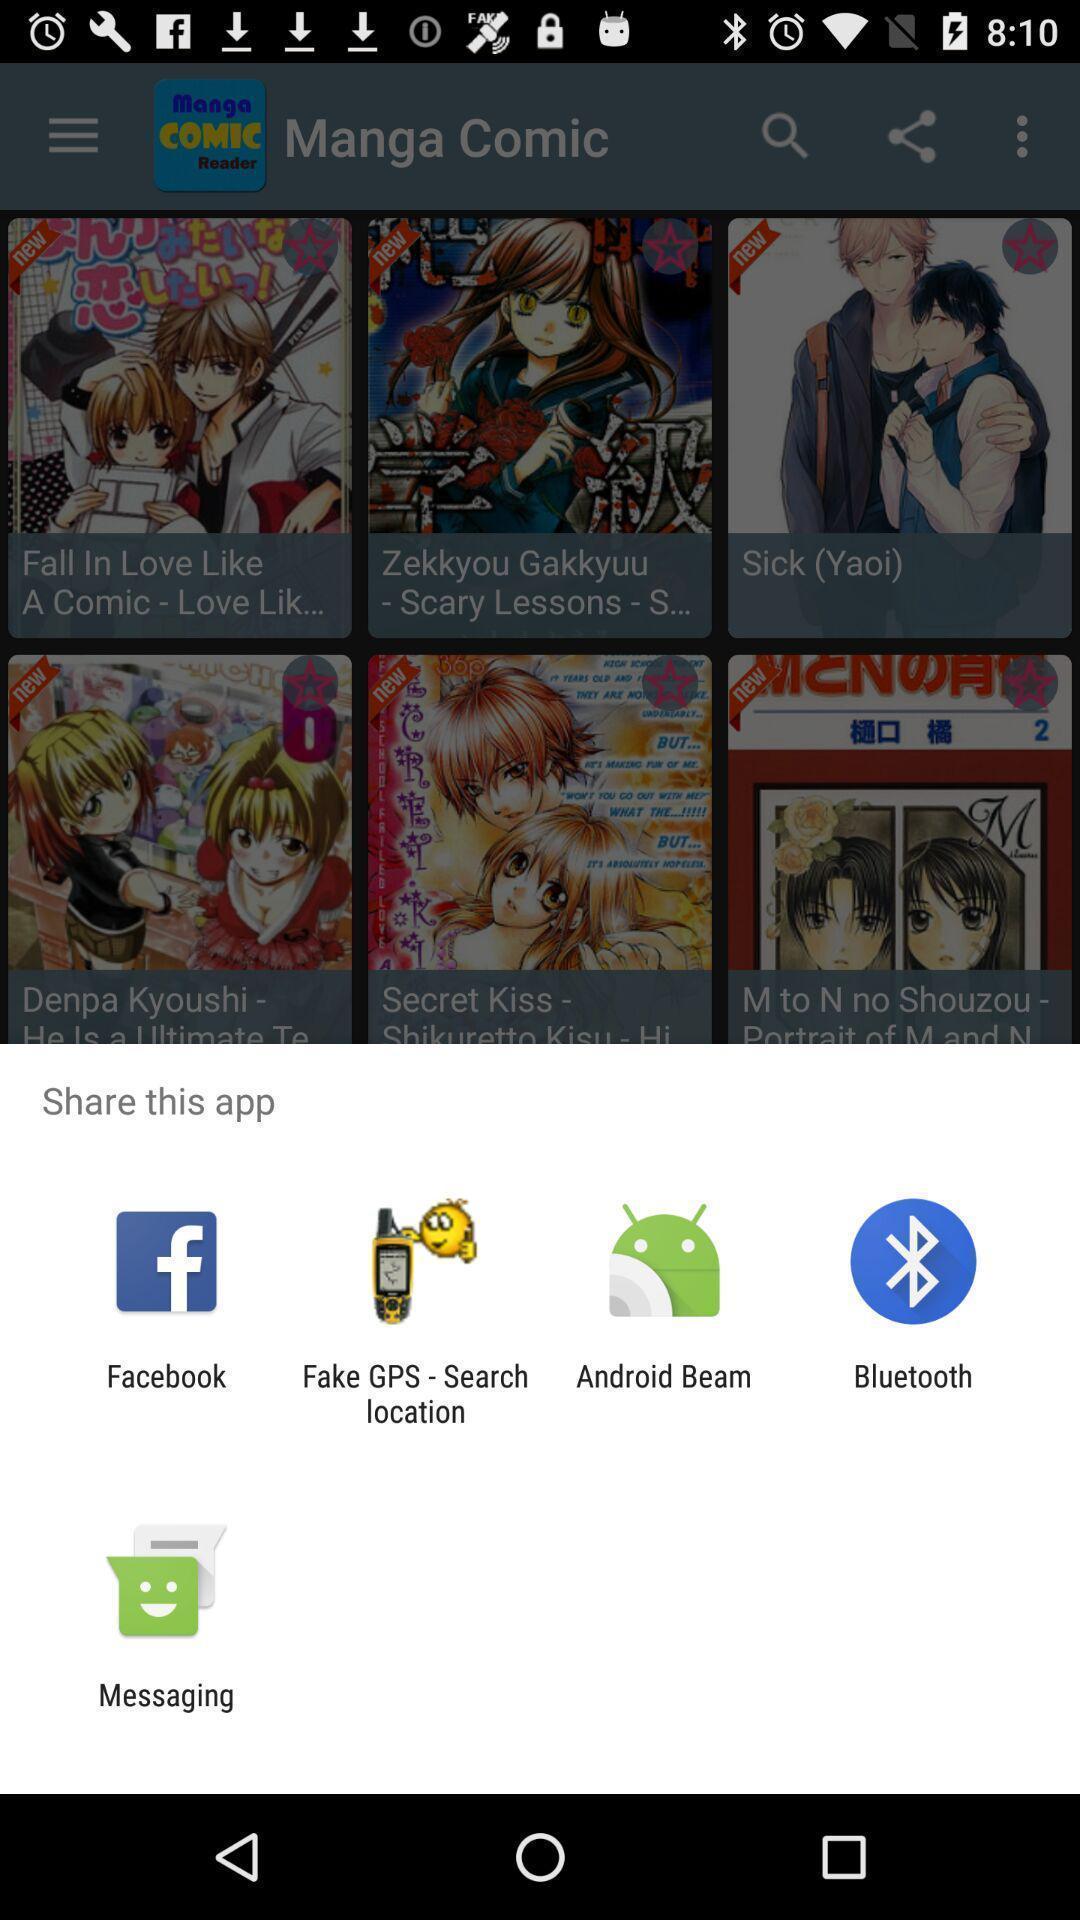What is the overall content of this screenshot? Push up page showing app preference to share. 